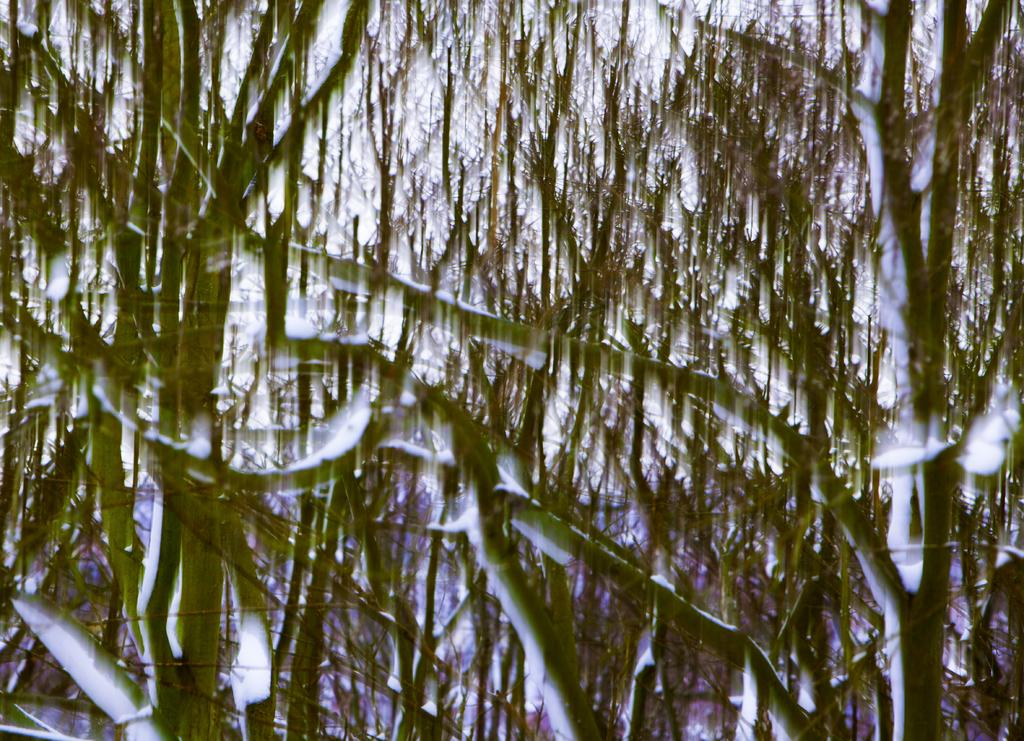What is the overall quality of the image? The image is blurry. What type of living organisms can be seen in the image? Plants can be seen in the image. What type of mouth can be seen on the plants in the image? There are no mouths present on the plants in the image, as plants do not have mouths. How many flies can be seen in the image? There are no flies present in the image. 